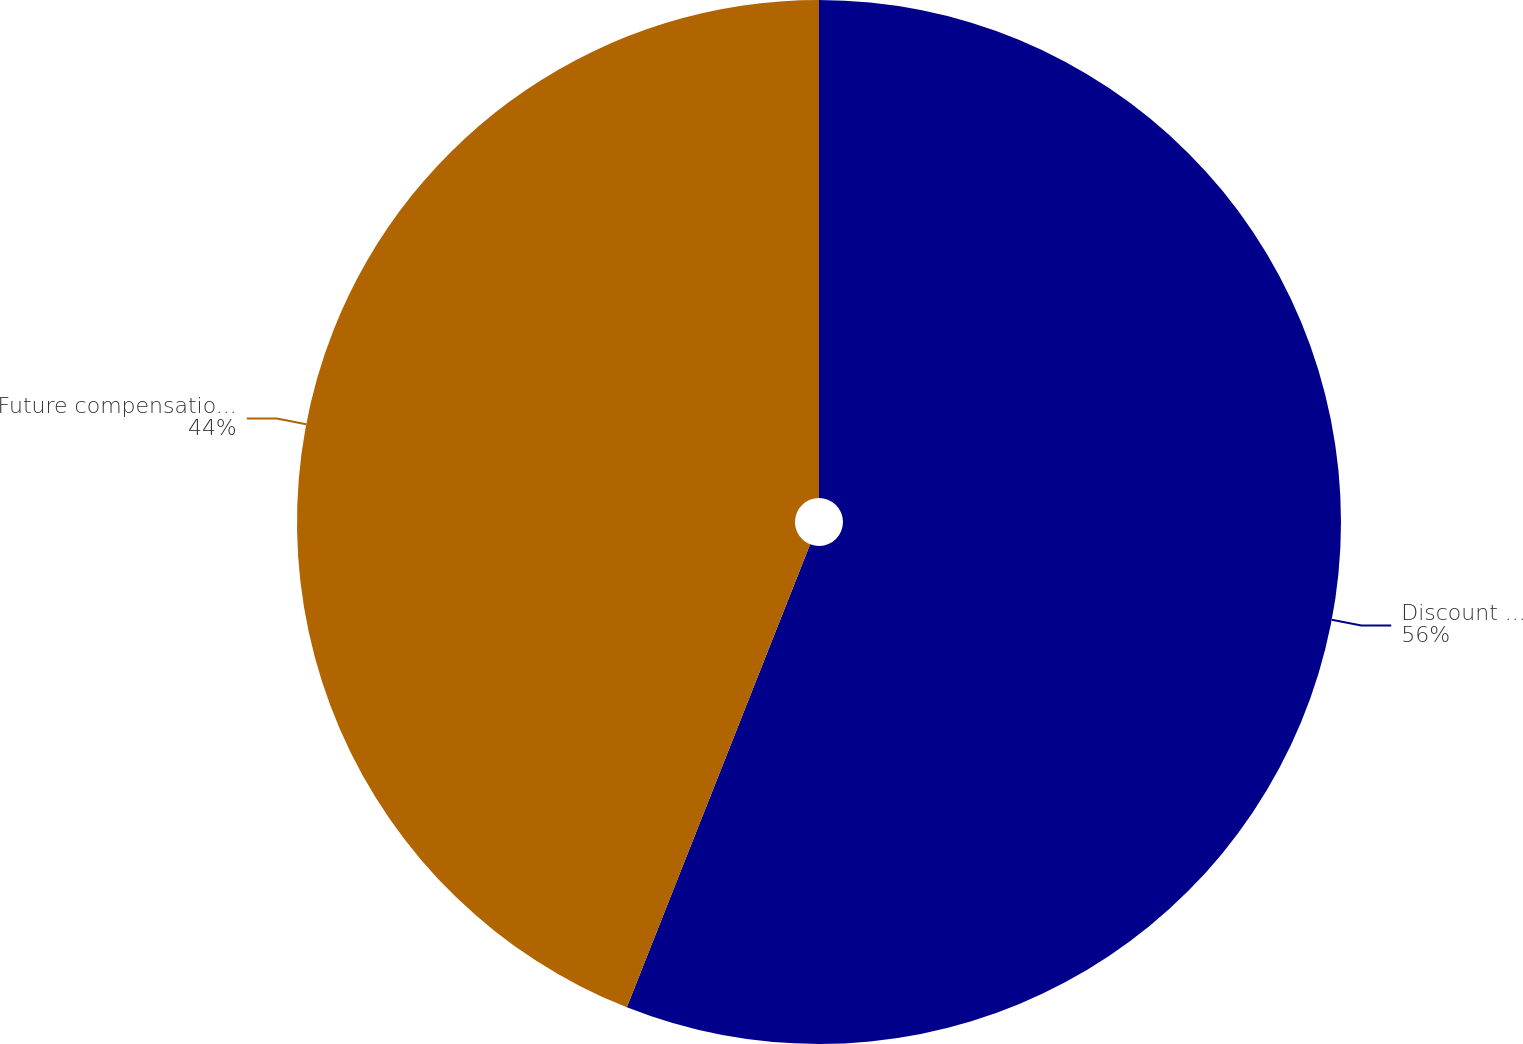Convert chart. <chart><loc_0><loc_0><loc_500><loc_500><pie_chart><fcel>Discount rate for obligations<fcel>Future compensation increase<nl><fcel>56.0%<fcel>44.0%<nl></chart> 